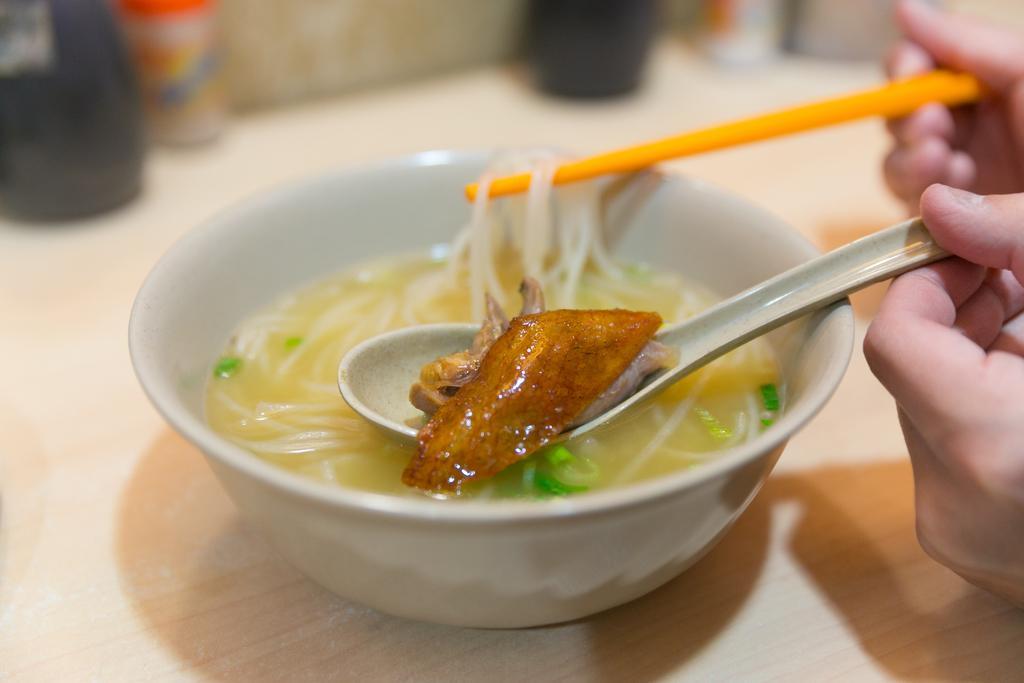Please provide a concise description of this image. On the table there is a white color bowl. In side the bowl there is a soup noodles , a person is holding a white spoon in their hand. In the spoon there is a food item. To the right top there is another hand holding chopsticks in their hand. On the top there are some bottles. 